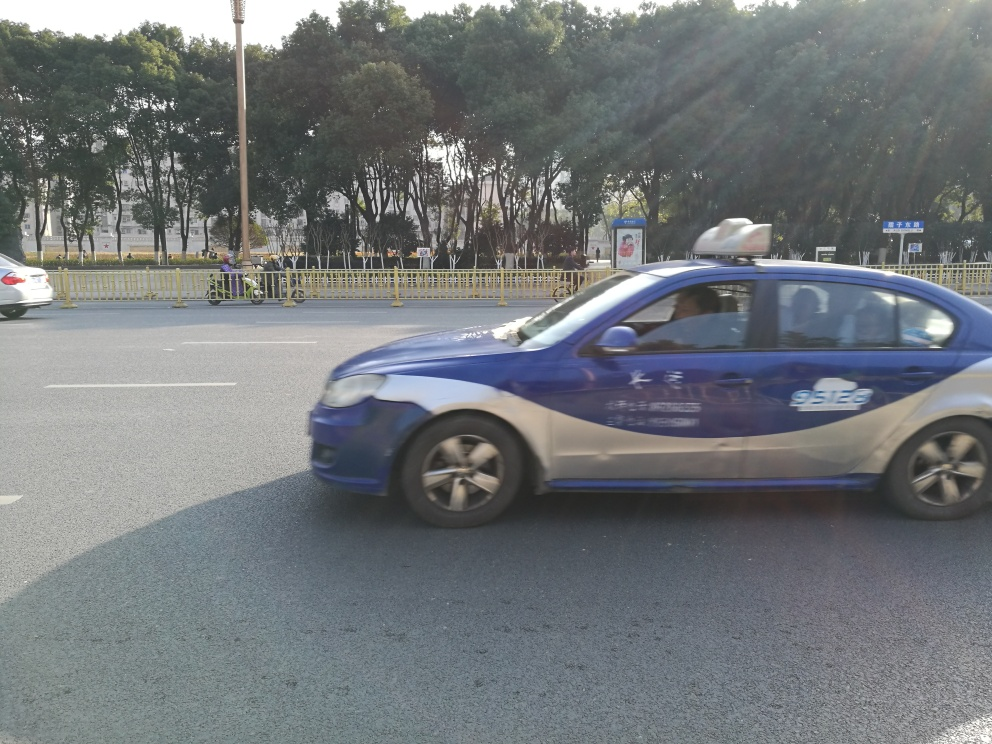What type of vehicle is in the picture? The vehicle in the picture is a blue sedan, with a distinctive taxi signage on top, suggesting it is a commercial taxi. 